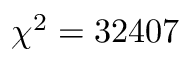<formula> <loc_0><loc_0><loc_500><loc_500>\chi ^ { 2 } = 3 2 4 0 7</formula> 